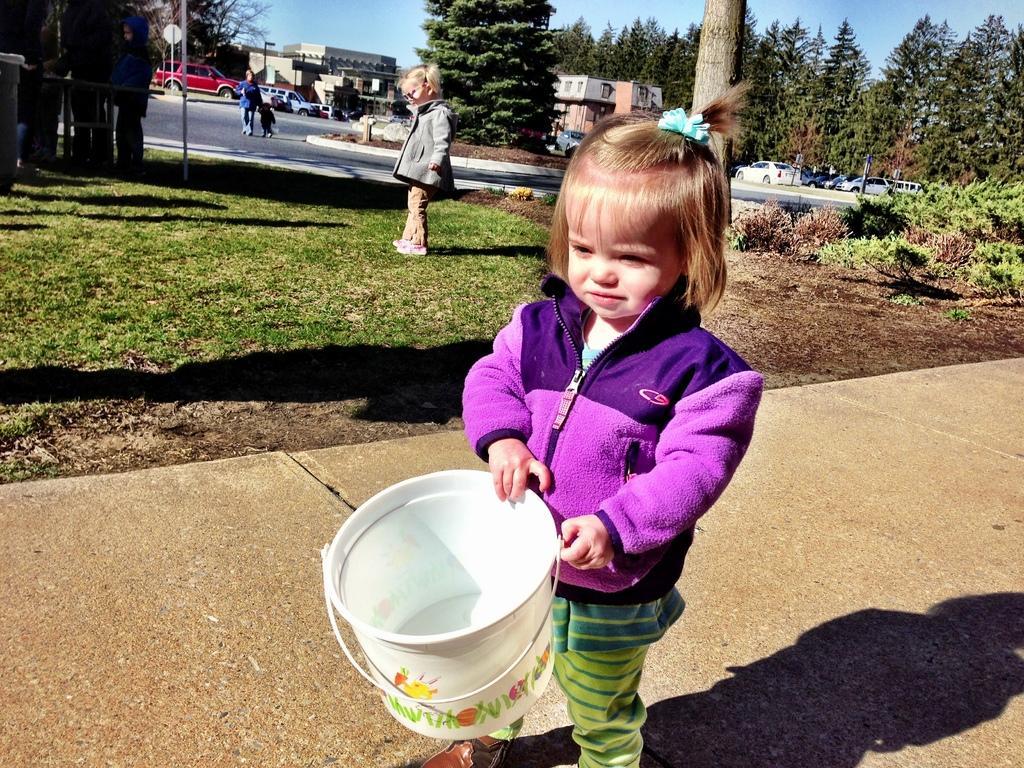In one or two sentences, can you explain what this image depicts? In this image we can see a child holding a bucket. In the back there is another child. On the ground there is grass. In the back there is a road. Also there are few people. Also there are vehicles, trees, buildings and there is sky. 